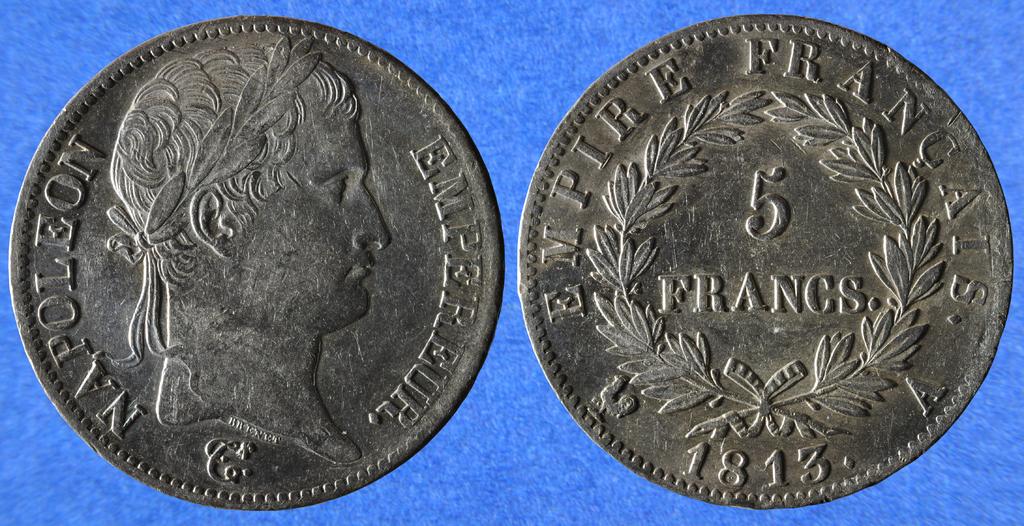What coin is this?
Your answer should be very brief. 5 francs. Whose name appears on this coin?
Ensure brevity in your answer.  Napoleon. 